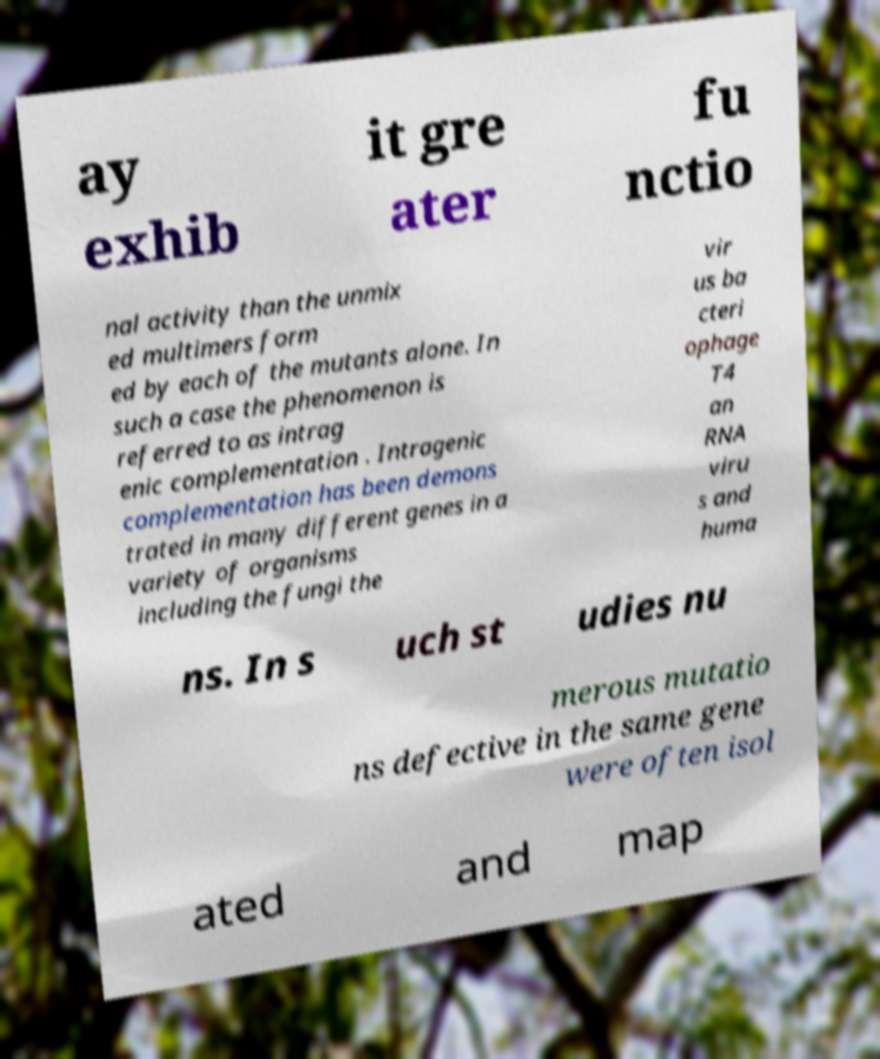There's text embedded in this image that I need extracted. Can you transcribe it verbatim? ay exhib it gre ater fu nctio nal activity than the unmix ed multimers form ed by each of the mutants alone. In such a case the phenomenon is referred to as intrag enic complementation . Intragenic complementation has been demons trated in many different genes in a variety of organisms including the fungi the vir us ba cteri ophage T4 an RNA viru s and huma ns. In s uch st udies nu merous mutatio ns defective in the same gene were often isol ated and map 